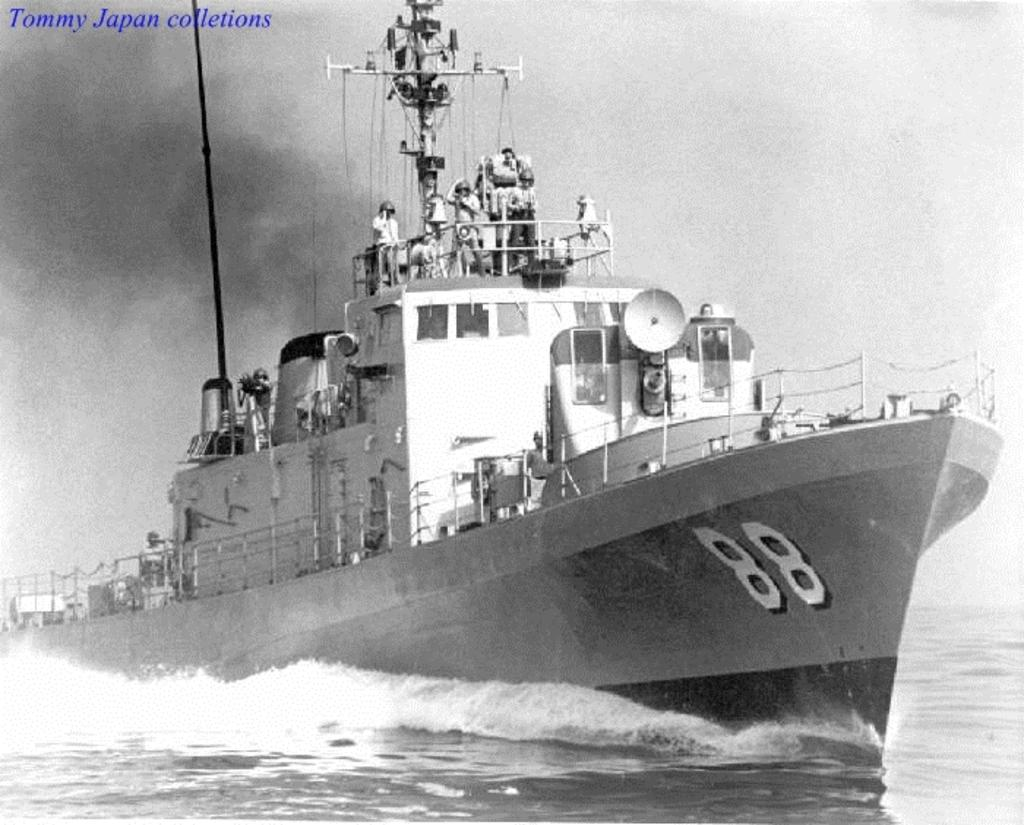What is the main subject of the image? The main subject of the image is people on a boat. What can be seen in the water around the boat? Waves are visible in the water. Is there any additional information or marking on the image? Yes, a watermark is present on the left side of the image. How does the boat use the brake to slow down in the image? There is no brake on the boat in the image, as boats do not have brakes like cars. What type of head is visible on the people in the image? The image does not show the people's heads, only their bodies on the boat. 